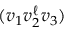Convert formula to latex. <formula><loc_0><loc_0><loc_500><loc_500>( v _ { 1 } v _ { 2 } ^ { \ell } v _ { 3 } )</formula> 